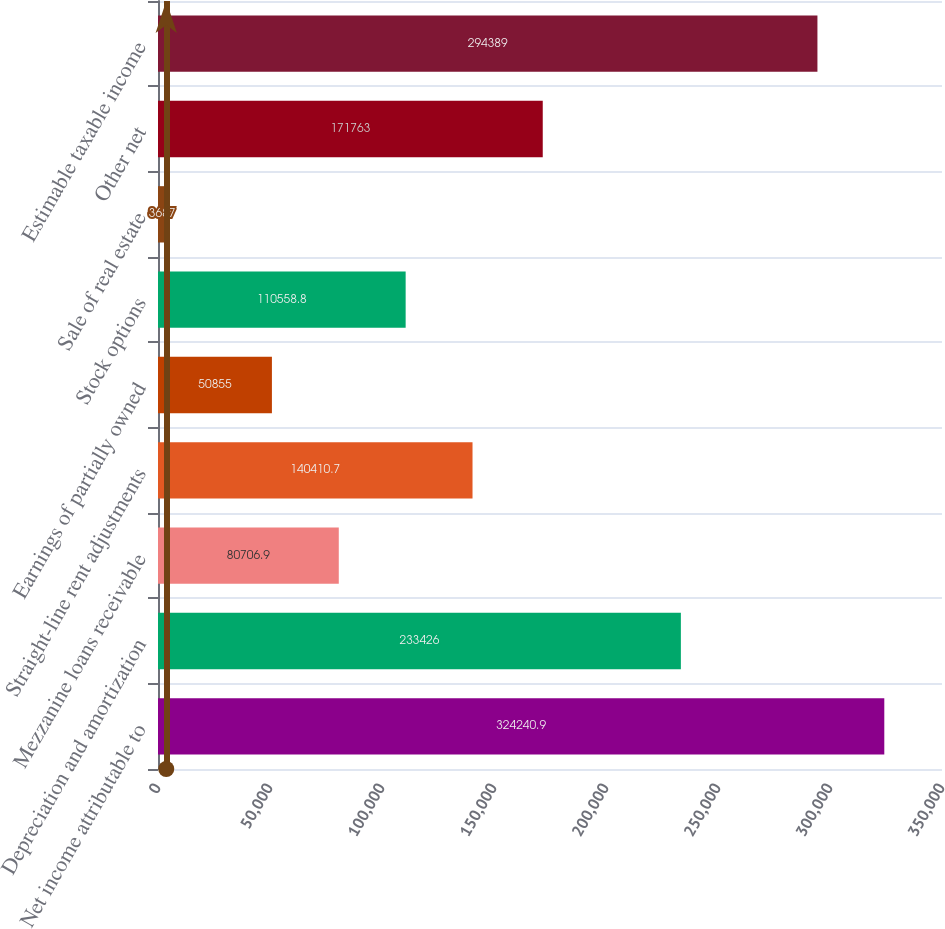<chart> <loc_0><loc_0><loc_500><loc_500><bar_chart><fcel>Net income attributable to<fcel>Depreciation and amortization<fcel>Mezzanine loans receivable<fcel>Straight-line rent adjustments<fcel>Earnings of partially owned<fcel>Stock options<fcel>Sale of real estate<fcel>Other net<fcel>Estimable taxable income<nl><fcel>324241<fcel>233426<fcel>80706.9<fcel>140411<fcel>50855<fcel>110559<fcel>3687<fcel>171763<fcel>294389<nl></chart> 